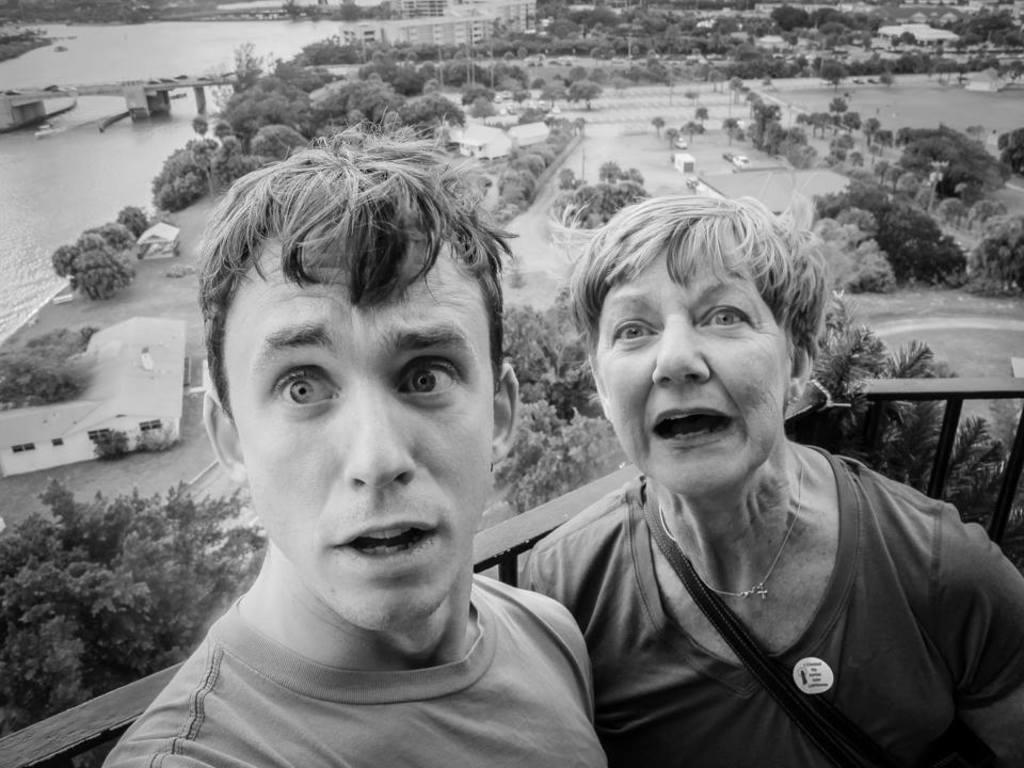What is the color scheme of the image? The image is black and white. How many people are present in the image? There is a man and a woman in the image. What are the facial expressions of the man and woman? Both the man and woman have their mouths open. What can be seen in the background of the image? There is a railing, trees, water, a bridge, and poles in the background of the image. What type of baseball equipment can be seen in the image? There is no baseball equipment present in the image. What currency is being exchanged between the man and woman in the image? There is no indication of any currency exchange or financial transaction in the image. 